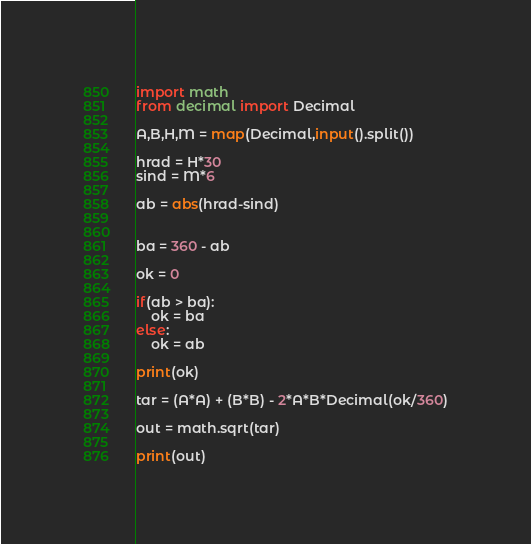Convert code to text. <code><loc_0><loc_0><loc_500><loc_500><_Python_>import math
from decimal import Decimal

A,B,H,M = map(Decimal,input().split())

hrad = H*30
sind = M*6

ab = abs(hrad-sind)


ba = 360 - ab

ok = 0

if(ab > ba):
    ok = ba
else:
    ok = ab

print(ok)

tar = (A*A) + (B*B) - 2*A*B*Decimal(ok/360)

out = math.sqrt(tar)

print(out)
</code> 